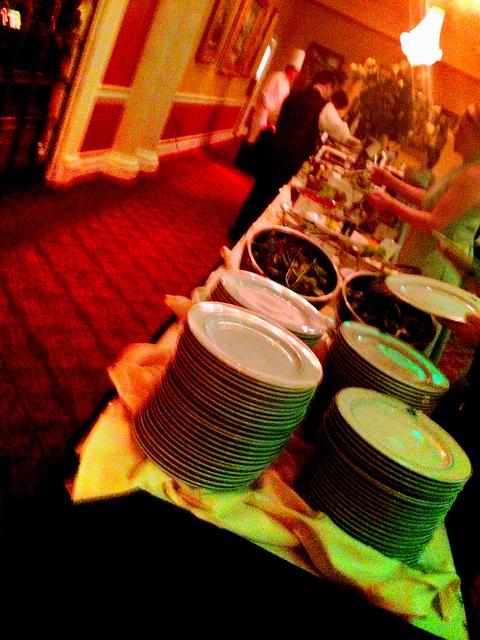Are the plates clean?
Give a very brief answer. Yes. Is this a picture of a buffet?
Answer briefly. Yes. What is the first stack of items to the left?
Answer briefly. Plates. 